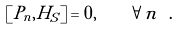<formula> <loc_0><loc_0><loc_500><loc_500>\left [ P _ { n } , H _ { S } \right ] = 0 , \quad \forall n \ .</formula> 